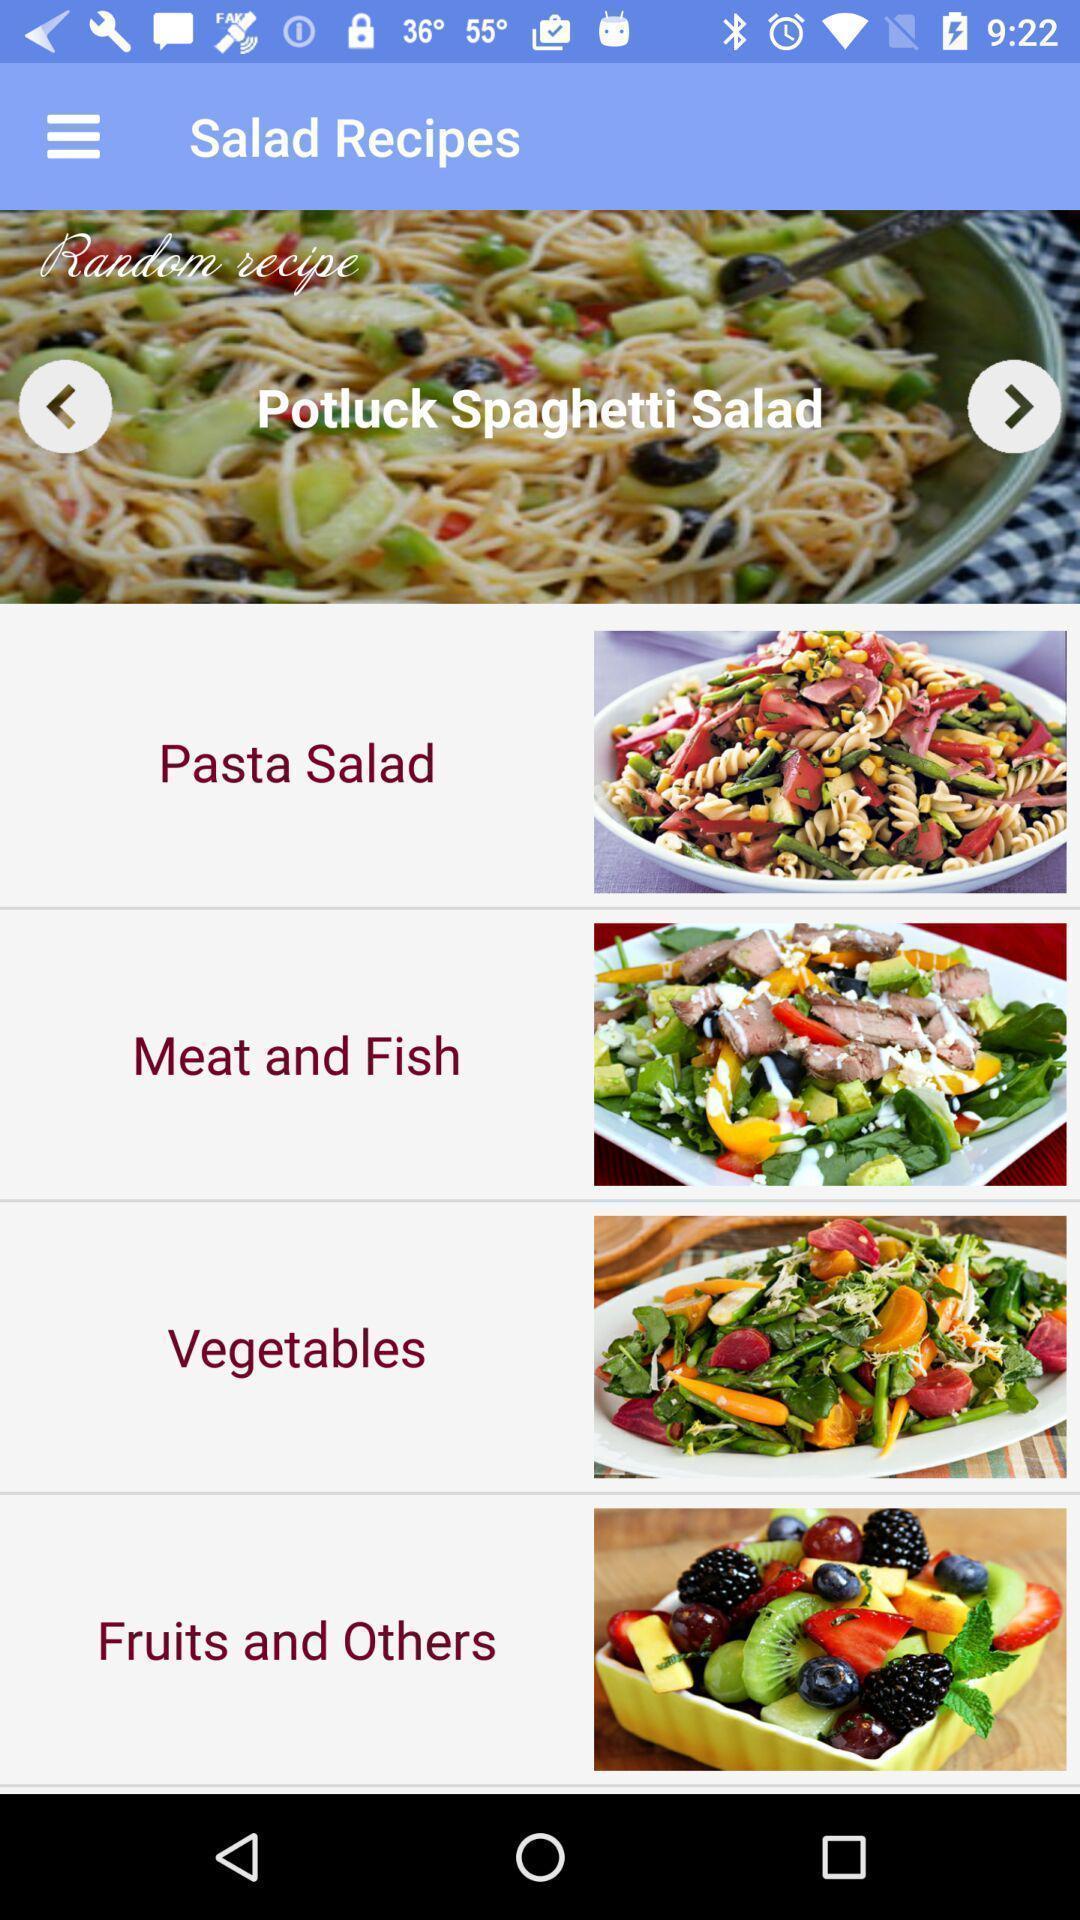Describe the visual elements of this screenshot. Page showing different recipes on a food app. 